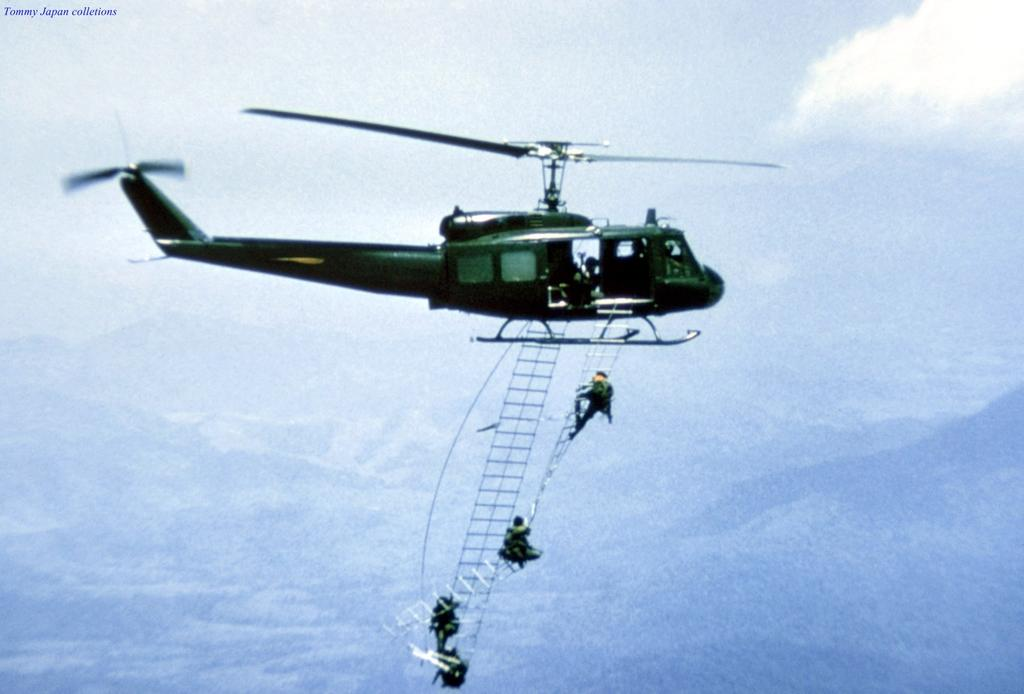What is the main subject of the image? The main subject of the image is an helicopter. What is the color of the helicopter? The helicopter is green in color. What feature can be seen on the helicopter? There are ladders on the helicopter. How many persons are on the ladders? There are 4 persons on the ladders. What is visible in the background of the image? The sky is visible in the image. What type of neck accessory is being worn by the rat in the image? There is no rat present in the image, and therefore no neck accessory can be observed. 